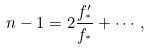Convert formula to latex. <formula><loc_0><loc_0><loc_500><loc_500>n - 1 = 2 \frac { f _ { ^ { * } } ^ { \prime } } { f _ { ^ { * } } } + \cdots \, ,</formula> 